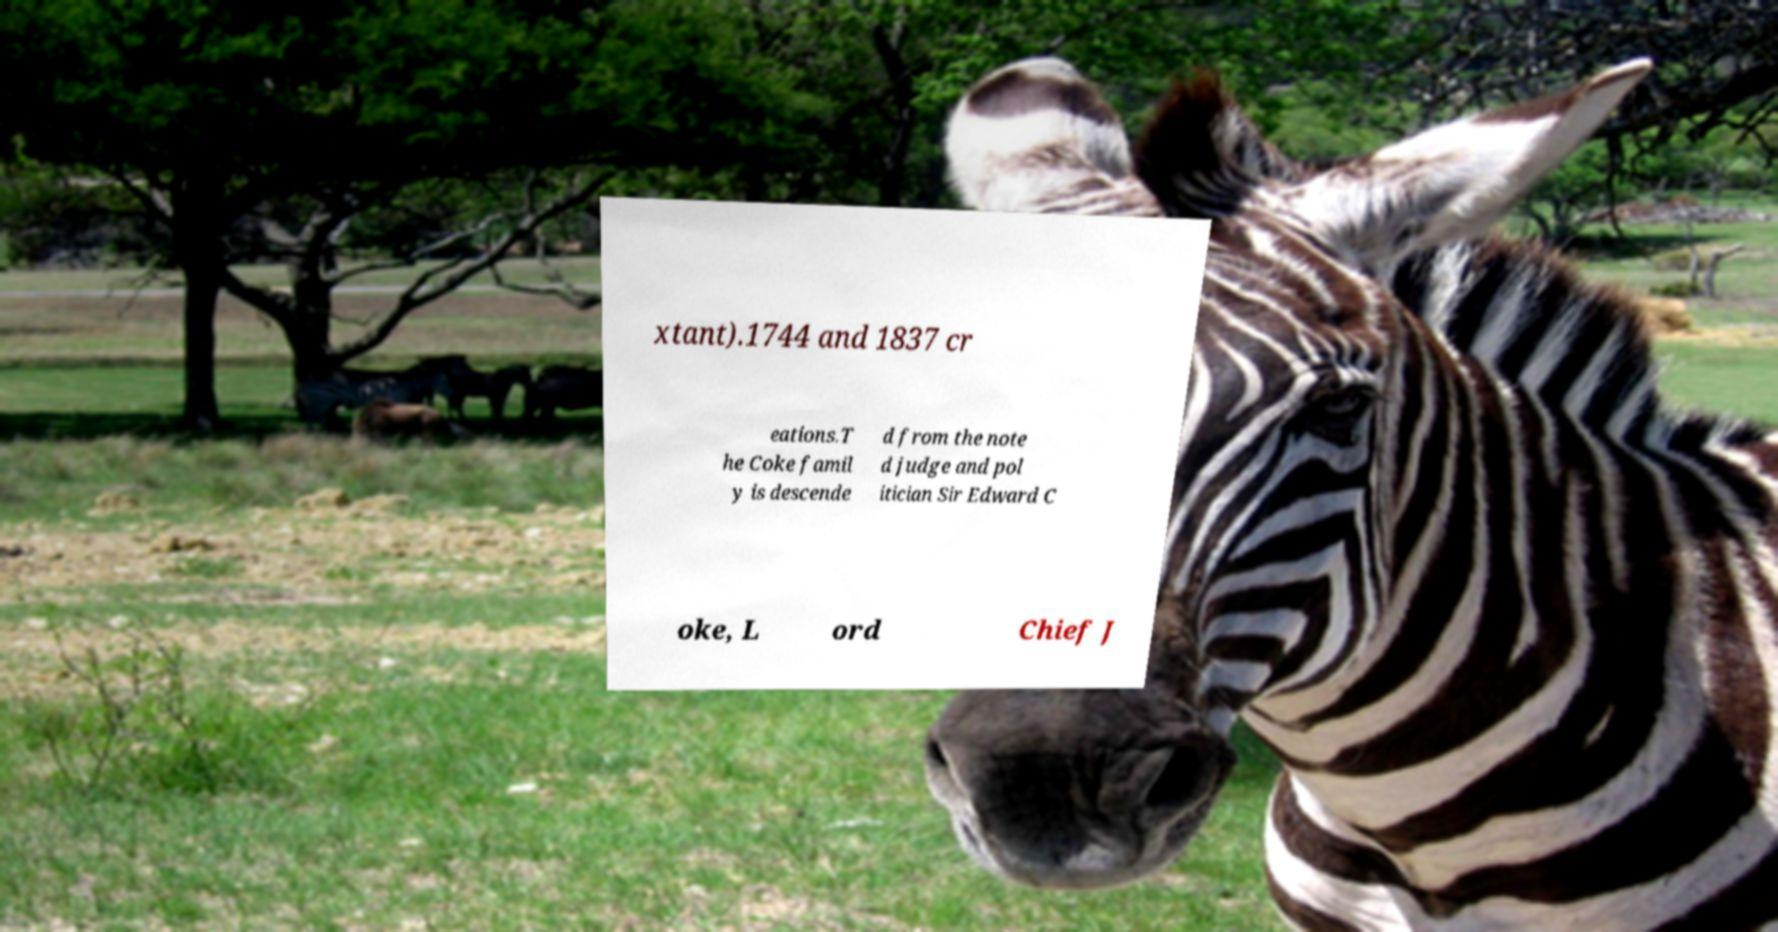Can you read and provide the text displayed in the image?This photo seems to have some interesting text. Can you extract and type it out for me? xtant).1744 and 1837 cr eations.T he Coke famil y is descende d from the note d judge and pol itician Sir Edward C oke, L ord Chief J 